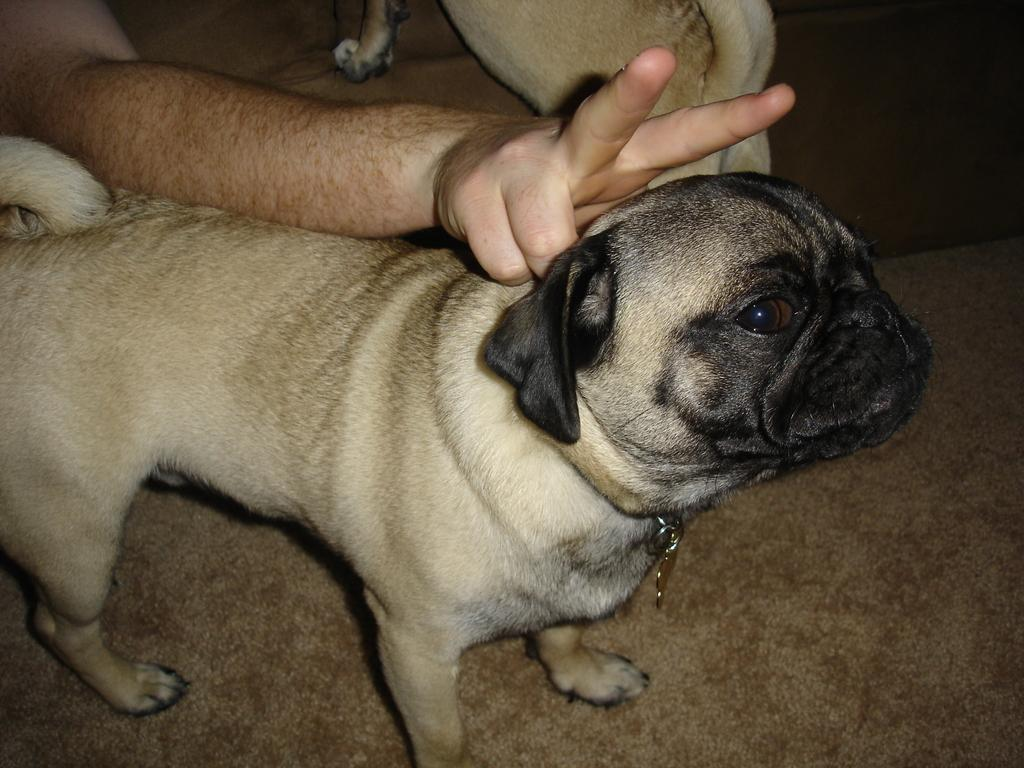What type of animals are present in the image? There are dogs in the image. Can you describe any human presence in the image? A person's hand is visible in the image. What type of breakfast is the person eating in the image? There is no breakfast visible in the image; only dogs and a person's hand are present. 